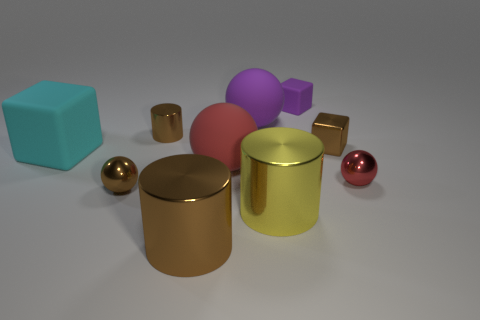What number of tiny green cylinders are there?
Provide a short and direct response. 0. Does the object behind the big purple object have the same size as the brown object to the right of the big purple rubber object?
Your response must be concise. Yes. What color is the other matte thing that is the same shape as the red matte thing?
Give a very brief answer. Purple. Do the small matte thing and the large brown object have the same shape?
Your response must be concise. No. What size is the brown metallic object that is the same shape as the small purple matte object?
Offer a very short reply. Small. How many big red spheres have the same material as the big purple sphere?
Offer a terse response. 1. How many objects are either red rubber cylinders or big rubber blocks?
Offer a very short reply. 1. Are there any red spheres behind the brown object that is on the right side of the big brown cylinder?
Keep it short and to the point. No. Are there more red rubber balls that are behind the purple rubber cube than brown balls behind the big cyan matte cube?
Your answer should be compact. No. There is another thing that is the same color as the small matte object; what is it made of?
Your answer should be compact. Rubber. 